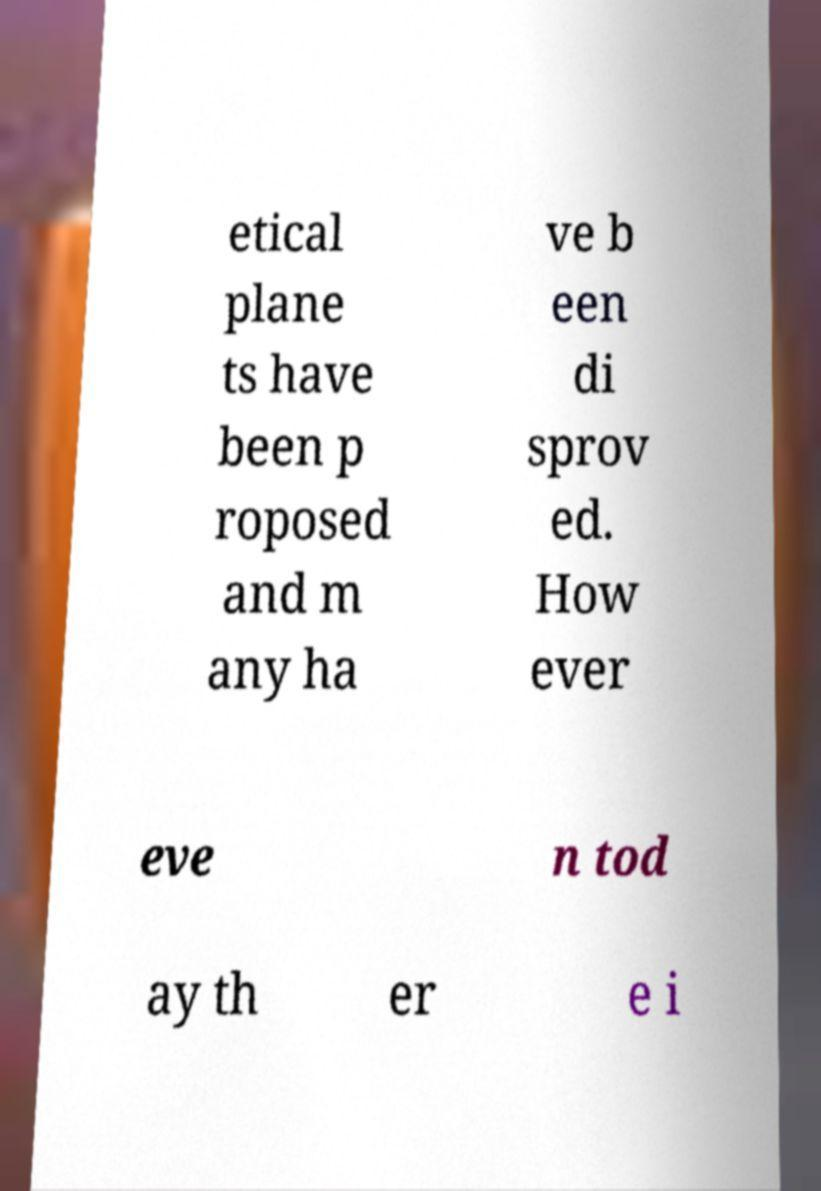Please read and relay the text visible in this image. What does it say? etical plane ts have been p roposed and m any ha ve b een di sprov ed. How ever eve n tod ay th er e i 